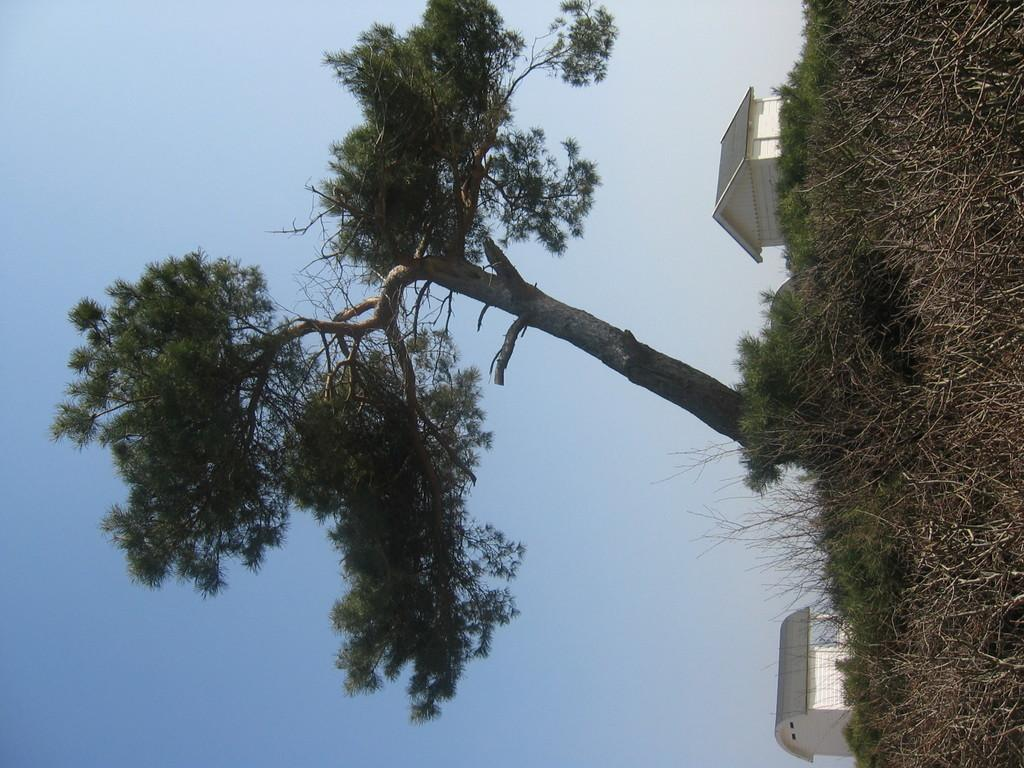What type of structures can be seen in the image? There are houses in the image. What other elements are present in the image besides houses? There are plants and a tree in the image. What can be seen in the background of the image? The sky is visible in the background of the image. What type of blade is being used to cut the nation in the image? There is no blade or nation present in the image; it features houses, plants, a tree, and the sky. 